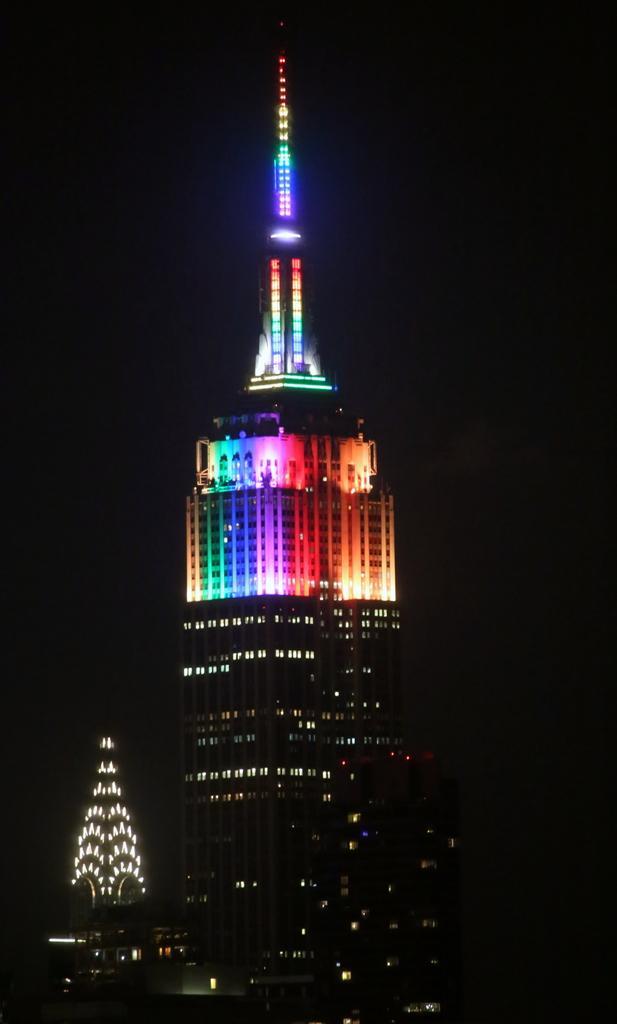Describe this image in one or two sentences. In this image I can see there are very big buildings with different color lights, at the top it is the sky in the night time. 